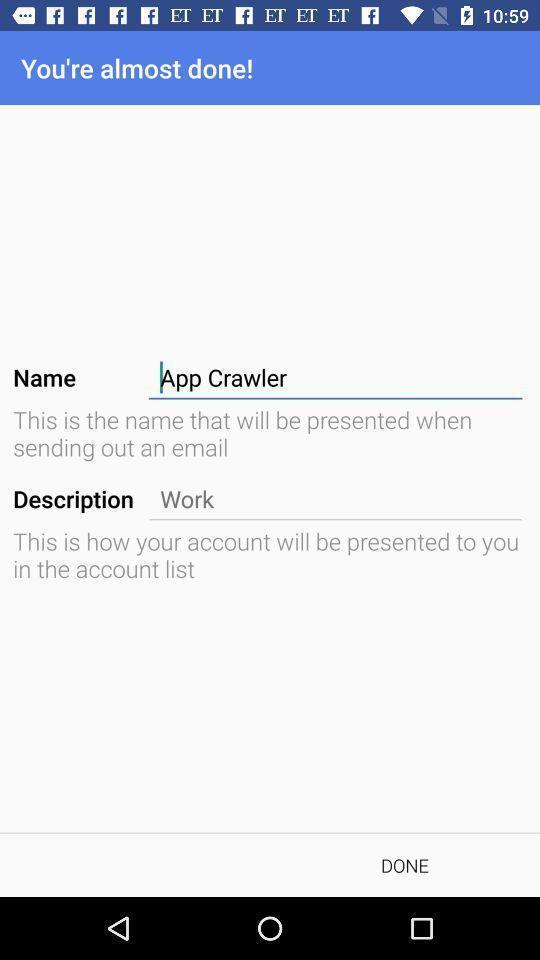Describe the content in this image. Signature setup page in a mailing app. 